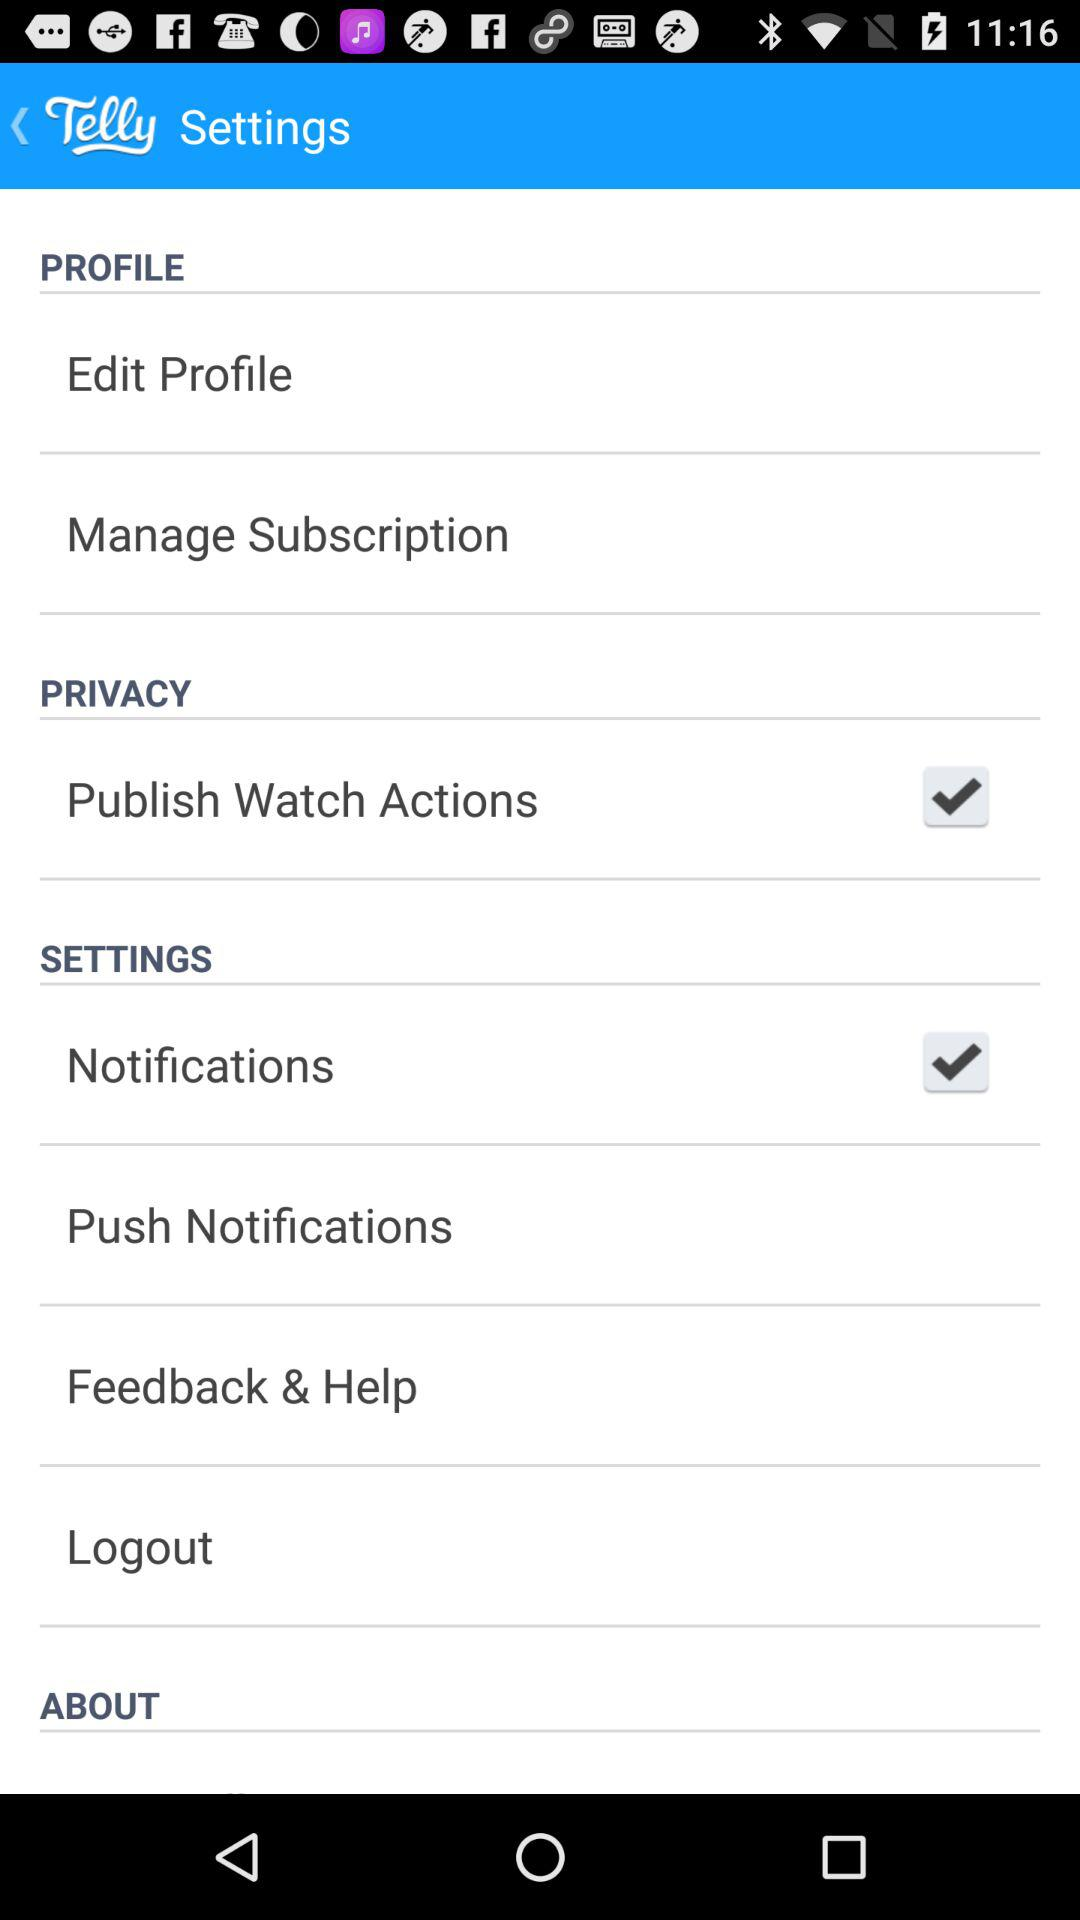What is the status of notifications? The status is on. 